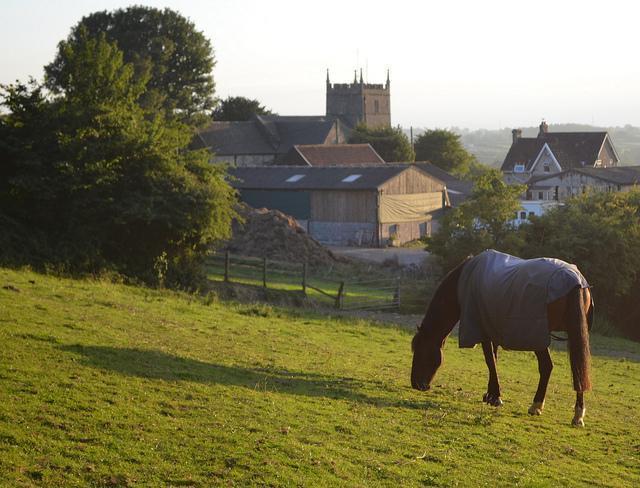How many horses are there?
Give a very brief answer. 1. How many horses are in the picture?
Give a very brief answer. 1. How many people are pictured?
Give a very brief answer. 0. 